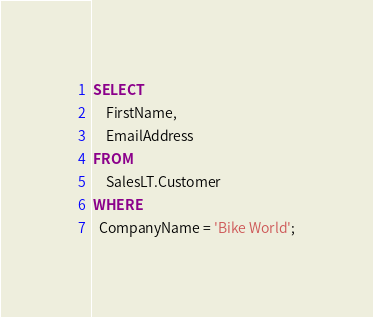<code> <loc_0><loc_0><loc_500><loc_500><_SQL_>SELECT
    FirstName,
    EmailAddress
FROM
    SalesLT.Customer
WHERE
  CompanyName = 'Bike World';</code> 